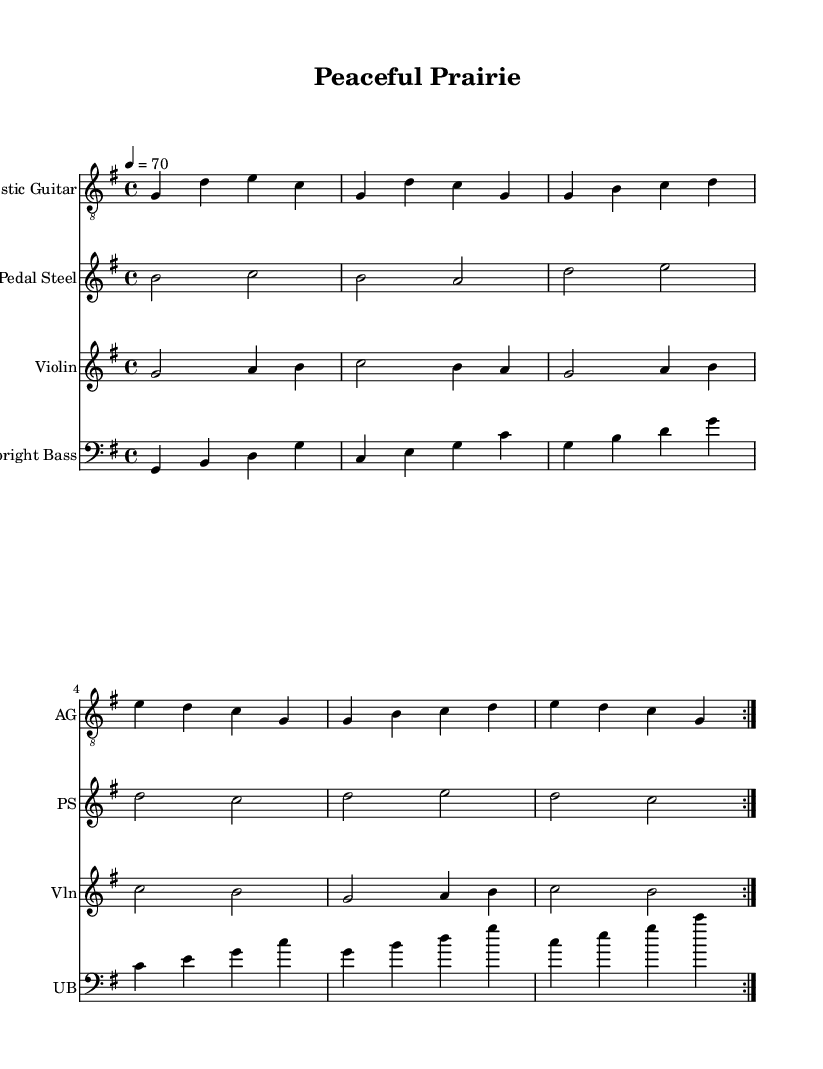What is the key signature of this music? The key signature is G major, which has one sharp (F#). The information can be found at the beginning of the score in the key signature section.
Answer: G major What is the time signature of this music? The time signature is 4/4, indicating that there are four beats per measure and each quarter note receives one beat. This can be identified at the beginning of the score, next to the key signature.
Answer: 4/4 What is the tempo marking for this piece? The tempo marking is 4 = 70, indicating the piece should be played at 70 beats per minute, with the note (quarter note) represented as a '4'. This is located just below the title at the start of the score.
Answer: 70 How many measures are in the repeating section for each instrument? Each instrument has a repeating section that lasts for 8 measures. This can be determined by counting the measures in the repeated volta sections indicated by the repeat signs.
Answer: 8 What are the instrumental parts featured in this piece? The piece features four instrumental parts: Acoustic Guitar, Pedal Steel, Violin, and Upright Bass. This is detailed at the beginning of each staff, noting the instrument names beside each music line.
Answer: Acoustic Guitar, Pedal Steel, Violin, Upright Bass Which instrument plays the melody prominently? The Acoustic Guitar plays the melody prominently throughout the piece, with its distinct chords and phrases clearly outlining the harmonic structure. This can be observed as it carries the main thematic material compared to the other parts.
Answer: Acoustic Guitar 